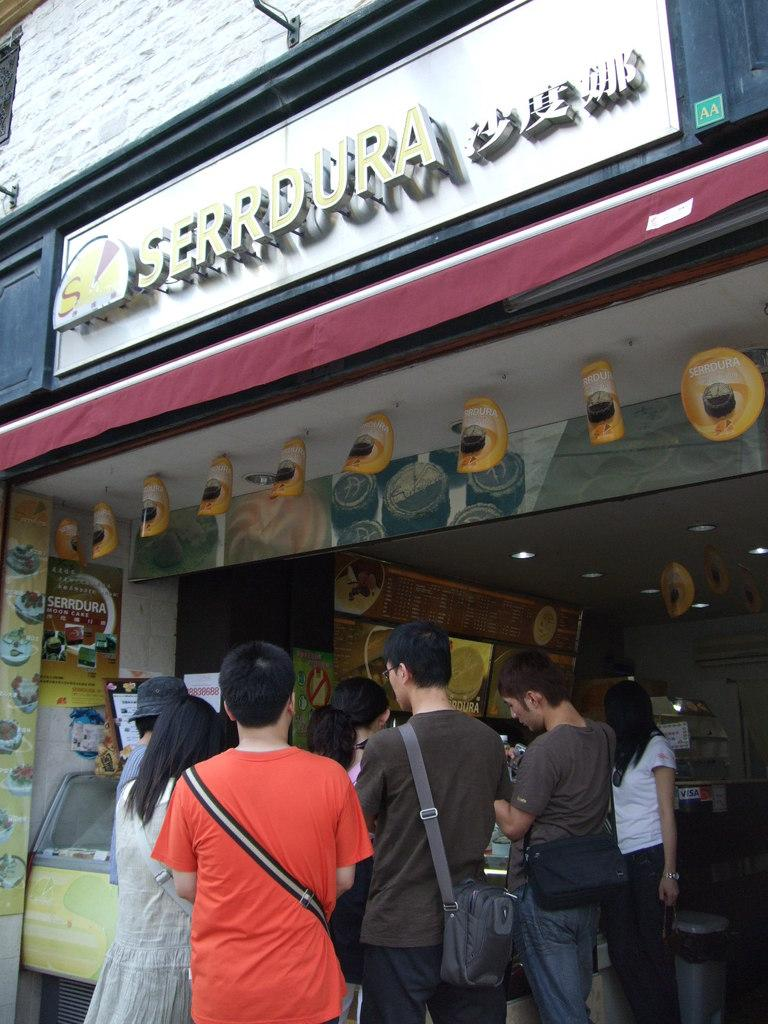What can be observed about the people in the image? There are people standing in the image. What type of location is depicted in the image? The place appears to be a store. What is the purpose of the board with text in the image? The board with text may contain information or promotions related to the store. Can you describe any other objects present in the image? There are other objects present in the image, but their specific details are not mentioned in the provided facts. How many muscles can be seen on the tree in the image? There is no tree present in the image, so it is not possible to determine the number of muscles on a tree. 